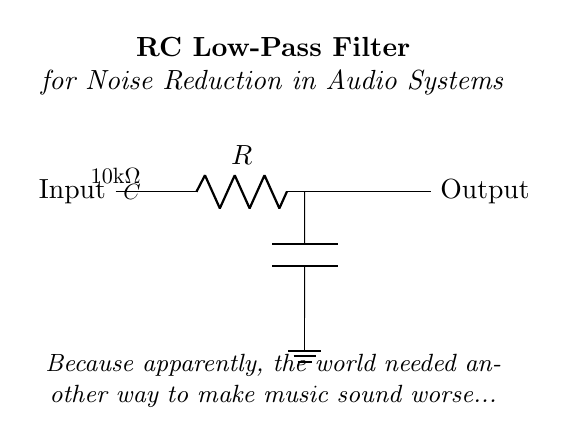What type of filter is represented in this circuit? The circuit indicates an RC low-pass filter, which allows low-frequency signals to pass while attenuating high-frequency signals. This is typically used in audio systems for noise reduction.
Answer: RC low-pass filter What is the resistance value in this circuit? The resistor in the circuit is labeled as 10k ohms, which is specified in the diagram above the resistor component.
Answer: 10k ohms What component is used to store charge in this circuit? The capacitor is responsible for storing charge in the circuit, as indicated by the "C" label in the diagram. Capacitors are commonly used for filtering applications in audio systems.
Answer: Capacitor How does the RC combination affect high-frequency signals? The RC combination acts to attenuate high-frequency signals, meaning that higher frequencies will be reduced in amplitude when passing through this filter, effectively filtering out noise that typically resides in that range.
Answer: Attenuate What is the purpose of the ground in this circuit? The ground serves as a reference point for voltage levels in the circuit, providing a common return path for current. It stabilizes the circuit and aids in filtering by defining the low potential level for the capacitor.
Answer: Reference point In what application would you typically find this circuit used? This RC low-pass filter circuit is commonly found in audio systems, especially for reducing unwanted noise and ensuring that the output sound is clearer and less distorted.
Answer: Audio systems 